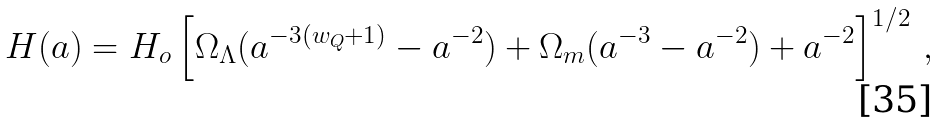Convert formula to latex. <formula><loc_0><loc_0><loc_500><loc_500>H ( a ) = H _ { o } \left [ \Omega _ { \Lambda } ( a ^ { - 3 ( w _ { Q } + 1 ) } - a ^ { - 2 } ) + \Omega _ { m } ( a ^ { - 3 } - a ^ { - 2 } ) + a ^ { - 2 } \right ] ^ { 1 / 2 } \, ,</formula> 